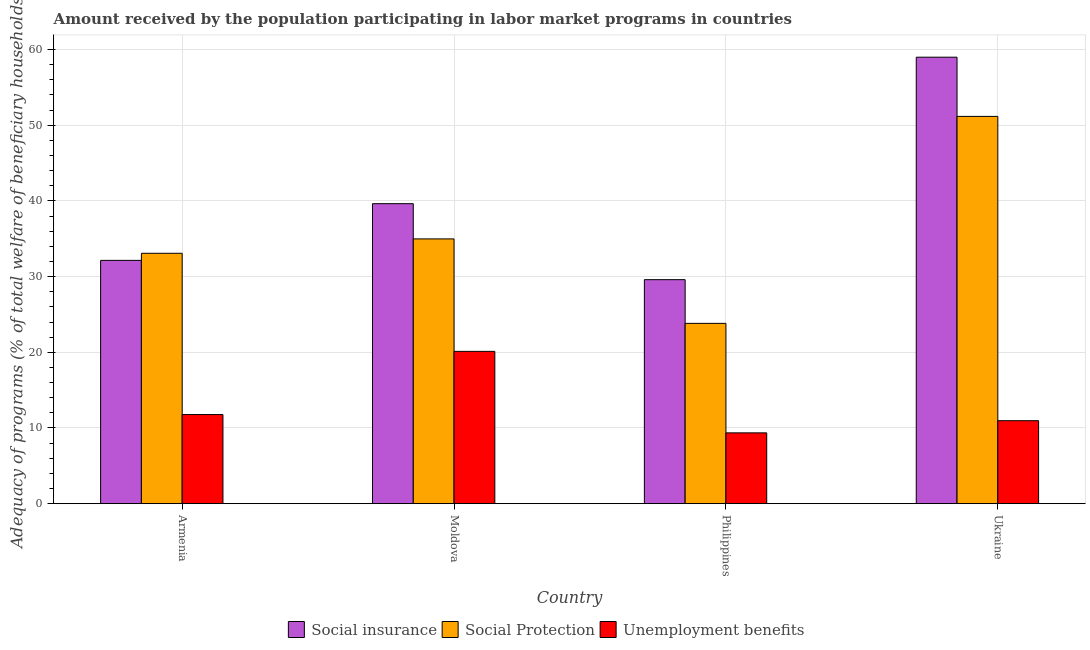How many bars are there on the 4th tick from the left?
Make the answer very short. 3. How many bars are there on the 3rd tick from the right?
Your response must be concise. 3. What is the label of the 1st group of bars from the left?
Your answer should be compact. Armenia. What is the amount received by the population participating in social insurance programs in Moldova?
Make the answer very short. 39.64. Across all countries, what is the maximum amount received by the population participating in social insurance programs?
Keep it short and to the point. 58.99. Across all countries, what is the minimum amount received by the population participating in social insurance programs?
Provide a short and direct response. 29.6. In which country was the amount received by the population participating in social protection programs maximum?
Your answer should be compact. Ukraine. In which country was the amount received by the population participating in social insurance programs minimum?
Offer a very short reply. Philippines. What is the total amount received by the population participating in unemployment benefits programs in the graph?
Offer a very short reply. 52.21. What is the difference between the amount received by the population participating in social insurance programs in Moldova and that in Philippines?
Provide a succinct answer. 10.04. What is the difference between the amount received by the population participating in unemployment benefits programs in Ukraine and the amount received by the population participating in social protection programs in Moldova?
Ensure brevity in your answer.  -24.02. What is the average amount received by the population participating in social insurance programs per country?
Ensure brevity in your answer.  40.09. What is the difference between the amount received by the population participating in social protection programs and amount received by the population participating in unemployment benefits programs in Philippines?
Keep it short and to the point. 14.47. In how many countries, is the amount received by the population participating in unemployment benefits programs greater than 6 %?
Offer a terse response. 4. What is the ratio of the amount received by the population participating in unemployment benefits programs in Moldova to that in Philippines?
Offer a terse response. 2.15. Is the amount received by the population participating in social protection programs in Armenia less than that in Philippines?
Keep it short and to the point. No. What is the difference between the highest and the second highest amount received by the population participating in social protection programs?
Your answer should be compact. 16.19. What is the difference between the highest and the lowest amount received by the population participating in social insurance programs?
Your response must be concise. 29.4. What does the 2nd bar from the left in Moldova represents?
Ensure brevity in your answer.  Social Protection. What does the 3rd bar from the right in Philippines represents?
Your response must be concise. Social insurance. Is it the case that in every country, the sum of the amount received by the population participating in social insurance programs and amount received by the population participating in social protection programs is greater than the amount received by the population participating in unemployment benefits programs?
Make the answer very short. Yes. How many bars are there?
Keep it short and to the point. 12. Are all the bars in the graph horizontal?
Your answer should be compact. No. How many countries are there in the graph?
Provide a succinct answer. 4. Are the values on the major ticks of Y-axis written in scientific E-notation?
Offer a very short reply. No. How are the legend labels stacked?
Keep it short and to the point. Horizontal. What is the title of the graph?
Give a very brief answer. Amount received by the population participating in labor market programs in countries. Does "Taxes on international trade" appear as one of the legend labels in the graph?
Offer a terse response. No. What is the label or title of the Y-axis?
Keep it short and to the point. Adequacy of programs (% of total welfare of beneficiary households). What is the Adequacy of programs (% of total welfare of beneficiary households) of Social insurance in Armenia?
Provide a short and direct response. 32.15. What is the Adequacy of programs (% of total welfare of beneficiary households) of Social Protection in Armenia?
Provide a succinct answer. 33.08. What is the Adequacy of programs (% of total welfare of beneficiary households) in Unemployment benefits in Armenia?
Provide a short and direct response. 11.77. What is the Adequacy of programs (% of total welfare of beneficiary households) of Social insurance in Moldova?
Ensure brevity in your answer.  39.64. What is the Adequacy of programs (% of total welfare of beneficiary households) in Social Protection in Moldova?
Ensure brevity in your answer.  34.98. What is the Adequacy of programs (% of total welfare of beneficiary households) of Unemployment benefits in Moldova?
Make the answer very short. 20.12. What is the Adequacy of programs (% of total welfare of beneficiary households) of Social insurance in Philippines?
Ensure brevity in your answer.  29.6. What is the Adequacy of programs (% of total welfare of beneficiary households) of Social Protection in Philippines?
Give a very brief answer. 23.82. What is the Adequacy of programs (% of total welfare of beneficiary households) of Unemployment benefits in Philippines?
Offer a very short reply. 9.35. What is the Adequacy of programs (% of total welfare of beneficiary households) of Social insurance in Ukraine?
Ensure brevity in your answer.  58.99. What is the Adequacy of programs (% of total welfare of beneficiary households) in Social Protection in Ukraine?
Give a very brief answer. 51.17. What is the Adequacy of programs (% of total welfare of beneficiary households) in Unemployment benefits in Ukraine?
Offer a terse response. 10.96. Across all countries, what is the maximum Adequacy of programs (% of total welfare of beneficiary households) in Social insurance?
Provide a succinct answer. 58.99. Across all countries, what is the maximum Adequacy of programs (% of total welfare of beneficiary households) in Social Protection?
Provide a succinct answer. 51.17. Across all countries, what is the maximum Adequacy of programs (% of total welfare of beneficiary households) of Unemployment benefits?
Provide a short and direct response. 20.12. Across all countries, what is the minimum Adequacy of programs (% of total welfare of beneficiary households) in Social insurance?
Give a very brief answer. 29.6. Across all countries, what is the minimum Adequacy of programs (% of total welfare of beneficiary households) in Social Protection?
Offer a terse response. 23.82. Across all countries, what is the minimum Adequacy of programs (% of total welfare of beneficiary households) in Unemployment benefits?
Give a very brief answer. 9.35. What is the total Adequacy of programs (% of total welfare of beneficiary households) of Social insurance in the graph?
Offer a very short reply. 160.38. What is the total Adequacy of programs (% of total welfare of beneficiary households) of Social Protection in the graph?
Offer a very short reply. 143.06. What is the total Adequacy of programs (% of total welfare of beneficiary households) of Unemployment benefits in the graph?
Your answer should be compact. 52.21. What is the difference between the Adequacy of programs (% of total welfare of beneficiary households) in Social insurance in Armenia and that in Moldova?
Make the answer very short. -7.49. What is the difference between the Adequacy of programs (% of total welfare of beneficiary households) in Social Protection in Armenia and that in Moldova?
Provide a succinct answer. -1.9. What is the difference between the Adequacy of programs (% of total welfare of beneficiary households) in Unemployment benefits in Armenia and that in Moldova?
Ensure brevity in your answer.  -8.35. What is the difference between the Adequacy of programs (% of total welfare of beneficiary households) of Social insurance in Armenia and that in Philippines?
Keep it short and to the point. 2.55. What is the difference between the Adequacy of programs (% of total welfare of beneficiary households) of Social Protection in Armenia and that in Philippines?
Provide a short and direct response. 9.26. What is the difference between the Adequacy of programs (% of total welfare of beneficiary households) in Unemployment benefits in Armenia and that in Philippines?
Your answer should be compact. 2.42. What is the difference between the Adequacy of programs (% of total welfare of beneficiary households) in Social insurance in Armenia and that in Ukraine?
Offer a very short reply. -26.85. What is the difference between the Adequacy of programs (% of total welfare of beneficiary households) of Social Protection in Armenia and that in Ukraine?
Provide a succinct answer. -18.09. What is the difference between the Adequacy of programs (% of total welfare of beneficiary households) in Unemployment benefits in Armenia and that in Ukraine?
Your answer should be very brief. 0.81. What is the difference between the Adequacy of programs (% of total welfare of beneficiary households) of Social insurance in Moldova and that in Philippines?
Offer a terse response. 10.04. What is the difference between the Adequacy of programs (% of total welfare of beneficiary households) in Social Protection in Moldova and that in Philippines?
Make the answer very short. 11.16. What is the difference between the Adequacy of programs (% of total welfare of beneficiary households) of Unemployment benefits in Moldova and that in Philippines?
Offer a very short reply. 10.77. What is the difference between the Adequacy of programs (% of total welfare of beneficiary households) in Social insurance in Moldova and that in Ukraine?
Make the answer very short. -19.36. What is the difference between the Adequacy of programs (% of total welfare of beneficiary households) in Social Protection in Moldova and that in Ukraine?
Offer a very short reply. -16.19. What is the difference between the Adequacy of programs (% of total welfare of beneficiary households) in Unemployment benefits in Moldova and that in Ukraine?
Your answer should be very brief. 9.16. What is the difference between the Adequacy of programs (% of total welfare of beneficiary households) in Social insurance in Philippines and that in Ukraine?
Your response must be concise. -29.4. What is the difference between the Adequacy of programs (% of total welfare of beneficiary households) of Social Protection in Philippines and that in Ukraine?
Offer a very short reply. -27.35. What is the difference between the Adequacy of programs (% of total welfare of beneficiary households) of Unemployment benefits in Philippines and that in Ukraine?
Your response must be concise. -1.61. What is the difference between the Adequacy of programs (% of total welfare of beneficiary households) in Social insurance in Armenia and the Adequacy of programs (% of total welfare of beneficiary households) in Social Protection in Moldova?
Your answer should be compact. -2.84. What is the difference between the Adequacy of programs (% of total welfare of beneficiary households) of Social insurance in Armenia and the Adequacy of programs (% of total welfare of beneficiary households) of Unemployment benefits in Moldova?
Your response must be concise. 12.03. What is the difference between the Adequacy of programs (% of total welfare of beneficiary households) of Social Protection in Armenia and the Adequacy of programs (% of total welfare of beneficiary households) of Unemployment benefits in Moldova?
Keep it short and to the point. 12.96. What is the difference between the Adequacy of programs (% of total welfare of beneficiary households) in Social insurance in Armenia and the Adequacy of programs (% of total welfare of beneficiary households) in Social Protection in Philippines?
Ensure brevity in your answer.  8.32. What is the difference between the Adequacy of programs (% of total welfare of beneficiary households) in Social insurance in Armenia and the Adequacy of programs (% of total welfare of beneficiary households) in Unemployment benefits in Philippines?
Make the answer very short. 22.79. What is the difference between the Adequacy of programs (% of total welfare of beneficiary households) of Social Protection in Armenia and the Adequacy of programs (% of total welfare of beneficiary households) of Unemployment benefits in Philippines?
Offer a terse response. 23.73. What is the difference between the Adequacy of programs (% of total welfare of beneficiary households) of Social insurance in Armenia and the Adequacy of programs (% of total welfare of beneficiary households) of Social Protection in Ukraine?
Offer a terse response. -19.02. What is the difference between the Adequacy of programs (% of total welfare of beneficiary households) in Social insurance in Armenia and the Adequacy of programs (% of total welfare of beneficiary households) in Unemployment benefits in Ukraine?
Provide a short and direct response. 21.19. What is the difference between the Adequacy of programs (% of total welfare of beneficiary households) in Social Protection in Armenia and the Adequacy of programs (% of total welfare of beneficiary households) in Unemployment benefits in Ukraine?
Your answer should be very brief. 22.12. What is the difference between the Adequacy of programs (% of total welfare of beneficiary households) of Social insurance in Moldova and the Adequacy of programs (% of total welfare of beneficiary households) of Social Protection in Philippines?
Your answer should be compact. 15.81. What is the difference between the Adequacy of programs (% of total welfare of beneficiary households) of Social insurance in Moldova and the Adequacy of programs (% of total welfare of beneficiary households) of Unemployment benefits in Philippines?
Give a very brief answer. 30.28. What is the difference between the Adequacy of programs (% of total welfare of beneficiary households) of Social Protection in Moldova and the Adequacy of programs (% of total welfare of beneficiary households) of Unemployment benefits in Philippines?
Give a very brief answer. 25.63. What is the difference between the Adequacy of programs (% of total welfare of beneficiary households) in Social insurance in Moldova and the Adequacy of programs (% of total welfare of beneficiary households) in Social Protection in Ukraine?
Make the answer very short. -11.53. What is the difference between the Adequacy of programs (% of total welfare of beneficiary households) in Social insurance in Moldova and the Adequacy of programs (% of total welfare of beneficiary households) in Unemployment benefits in Ukraine?
Give a very brief answer. 28.68. What is the difference between the Adequacy of programs (% of total welfare of beneficiary households) in Social Protection in Moldova and the Adequacy of programs (% of total welfare of beneficiary households) in Unemployment benefits in Ukraine?
Offer a very short reply. 24.02. What is the difference between the Adequacy of programs (% of total welfare of beneficiary households) in Social insurance in Philippines and the Adequacy of programs (% of total welfare of beneficiary households) in Social Protection in Ukraine?
Offer a terse response. -21.57. What is the difference between the Adequacy of programs (% of total welfare of beneficiary households) in Social insurance in Philippines and the Adequacy of programs (% of total welfare of beneficiary households) in Unemployment benefits in Ukraine?
Provide a short and direct response. 18.64. What is the difference between the Adequacy of programs (% of total welfare of beneficiary households) in Social Protection in Philippines and the Adequacy of programs (% of total welfare of beneficiary households) in Unemployment benefits in Ukraine?
Make the answer very short. 12.86. What is the average Adequacy of programs (% of total welfare of beneficiary households) of Social insurance per country?
Give a very brief answer. 40.09. What is the average Adequacy of programs (% of total welfare of beneficiary households) in Social Protection per country?
Offer a terse response. 35.77. What is the average Adequacy of programs (% of total welfare of beneficiary households) of Unemployment benefits per country?
Give a very brief answer. 13.05. What is the difference between the Adequacy of programs (% of total welfare of beneficiary households) in Social insurance and Adequacy of programs (% of total welfare of beneficiary households) in Social Protection in Armenia?
Your answer should be compact. -0.94. What is the difference between the Adequacy of programs (% of total welfare of beneficiary households) in Social insurance and Adequacy of programs (% of total welfare of beneficiary households) in Unemployment benefits in Armenia?
Your response must be concise. 20.37. What is the difference between the Adequacy of programs (% of total welfare of beneficiary households) in Social Protection and Adequacy of programs (% of total welfare of beneficiary households) in Unemployment benefits in Armenia?
Your response must be concise. 21.31. What is the difference between the Adequacy of programs (% of total welfare of beneficiary households) in Social insurance and Adequacy of programs (% of total welfare of beneficiary households) in Social Protection in Moldova?
Offer a terse response. 4.65. What is the difference between the Adequacy of programs (% of total welfare of beneficiary households) of Social insurance and Adequacy of programs (% of total welfare of beneficiary households) of Unemployment benefits in Moldova?
Provide a short and direct response. 19.52. What is the difference between the Adequacy of programs (% of total welfare of beneficiary households) in Social Protection and Adequacy of programs (% of total welfare of beneficiary households) in Unemployment benefits in Moldova?
Your answer should be compact. 14.86. What is the difference between the Adequacy of programs (% of total welfare of beneficiary households) in Social insurance and Adequacy of programs (% of total welfare of beneficiary households) in Social Protection in Philippines?
Offer a very short reply. 5.78. What is the difference between the Adequacy of programs (% of total welfare of beneficiary households) of Social insurance and Adequacy of programs (% of total welfare of beneficiary households) of Unemployment benefits in Philippines?
Your answer should be compact. 20.25. What is the difference between the Adequacy of programs (% of total welfare of beneficiary households) in Social Protection and Adequacy of programs (% of total welfare of beneficiary households) in Unemployment benefits in Philippines?
Ensure brevity in your answer.  14.47. What is the difference between the Adequacy of programs (% of total welfare of beneficiary households) of Social insurance and Adequacy of programs (% of total welfare of beneficiary households) of Social Protection in Ukraine?
Your answer should be very brief. 7.82. What is the difference between the Adequacy of programs (% of total welfare of beneficiary households) of Social insurance and Adequacy of programs (% of total welfare of beneficiary households) of Unemployment benefits in Ukraine?
Your answer should be compact. 48.03. What is the difference between the Adequacy of programs (% of total welfare of beneficiary households) of Social Protection and Adequacy of programs (% of total welfare of beneficiary households) of Unemployment benefits in Ukraine?
Ensure brevity in your answer.  40.21. What is the ratio of the Adequacy of programs (% of total welfare of beneficiary households) of Social insurance in Armenia to that in Moldova?
Offer a very short reply. 0.81. What is the ratio of the Adequacy of programs (% of total welfare of beneficiary households) in Social Protection in Armenia to that in Moldova?
Offer a very short reply. 0.95. What is the ratio of the Adequacy of programs (% of total welfare of beneficiary households) in Unemployment benefits in Armenia to that in Moldova?
Provide a succinct answer. 0.59. What is the ratio of the Adequacy of programs (% of total welfare of beneficiary households) in Social insurance in Armenia to that in Philippines?
Provide a succinct answer. 1.09. What is the ratio of the Adequacy of programs (% of total welfare of beneficiary households) in Social Protection in Armenia to that in Philippines?
Make the answer very short. 1.39. What is the ratio of the Adequacy of programs (% of total welfare of beneficiary households) in Unemployment benefits in Armenia to that in Philippines?
Provide a short and direct response. 1.26. What is the ratio of the Adequacy of programs (% of total welfare of beneficiary households) of Social insurance in Armenia to that in Ukraine?
Give a very brief answer. 0.54. What is the ratio of the Adequacy of programs (% of total welfare of beneficiary households) in Social Protection in Armenia to that in Ukraine?
Provide a short and direct response. 0.65. What is the ratio of the Adequacy of programs (% of total welfare of beneficiary households) in Unemployment benefits in Armenia to that in Ukraine?
Offer a terse response. 1.07. What is the ratio of the Adequacy of programs (% of total welfare of beneficiary households) of Social insurance in Moldova to that in Philippines?
Give a very brief answer. 1.34. What is the ratio of the Adequacy of programs (% of total welfare of beneficiary households) in Social Protection in Moldova to that in Philippines?
Ensure brevity in your answer.  1.47. What is the ratio of the Adequacy of programs (% of total welfare of beneficiary households) of Unemployment benefits in Moldova to that in Philippines?
Make the answer very short. 2.15. What is the ratio of the Adequacy of programs (% of total welfare of beneficiary households) in Social insurance in Moldova to that in Ukraine?
Provide a succinct answer. 0.67. What is the ratio of the Adequacy of programs (% of total welfare of beneficiary households) in Social Protection in Moldova to that in Ukraine?
Your answer should be compact. 0.68. What is the ratio of the Adequacy of programs (% of total welfare of beneficiary households) of Unemployment benefits in Moldova to that in Ukraine?
Provide a short and direct response. 1.84. What is the ratio of the Adequacy of programs (% of total welfare of beneficiary households) in Social insurance in Philippines to that in Ukraine?
Provide a succinct answer. 0.5. What is the ratio of the Adequacy of programs (% of total welfare of beneficiary households) of Social Protection in Philippines to that in Ukraine?
Provide a succinct answer. 0.47. What is the ratio of the Adequacy of programs (% of total welfare of beneficiary households) of Unemployment benefits in Philippines to that in Ukraine?
Your answer should be very brief. 0.85. What is the difference between the highest and the second highest Adequacy of programs (% of total welfare of beneficiary households) in Social insurance?
Offer a very short reply. 19.36. What is the difference between the highest and the second highest Adequacy of programs (% of total welfare of beneficiary households) of Social Protection?
Provide a succinct answer. 16.19. What is the difference between the highest and the second highest Adequacy of programs (% of total welfare of beneficiary households) of Unemployment benefits?
Your response must be concise. 8.35. What is the difference between the highest and the lowest Adequacy of programs (% of total welfare of beneficiary households) in Social insurance?
Offer a very short reply. 29.4. What is the difference between the highest and the lowest Adequacy of programs (% of total welfare of beneficiary households) in Social Protection?
Offer a very short reply. 27.35. What is the difference between the highest and the lowest Adequacy of programs (% of total welfare of beneficiary households) in Unemployment benefits?
Give a very brief answer. 10.77. 